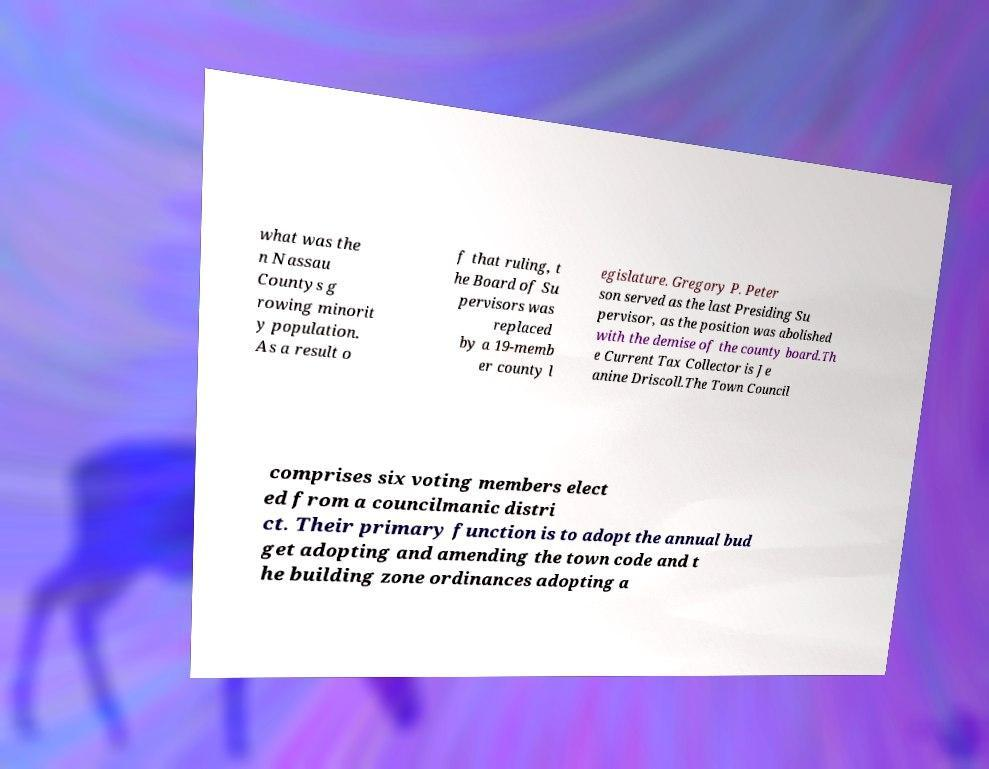What messages or text are displayed in this image? I need them in a readable, typed format. what was the n Nassau Countys g rowing minorit y population. As a result o f that ruling, t he Board of Su pervisors was replaced by a 19-memb er county l egislature. Gregory P. Peter son served as the last Presiding Su pervisor, as the position was abolished with the demise of the county board.Th e Current Tax Collector is Je anine Driscoll.The Town Council comprises six voting members elect ed from a councilmanic distri ct. Their primary function is to adopt the annual bud get adopting and amending the town code and t he building zone ordinances adopting a 